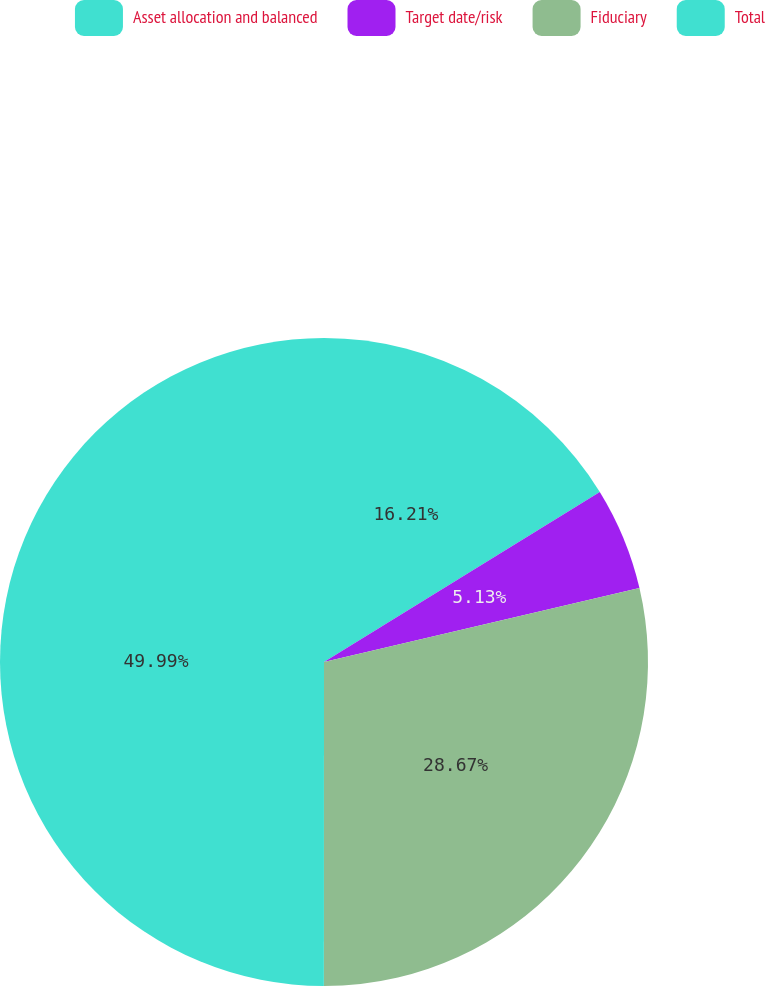Convert chart to OTSL. <chart><loc_0><loc_0><loc_500><loc_500><pie_chart><fcel>Asset allocation and balanced<fcel>Target date/risk<fcel>Fiduciary<fcel>Total<nl><fcel>16.21%<fcel>5.13%<fcel>28.67%<fcel>50.0%<nl></chart> 